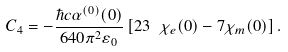<formula> <loc_0><loc_0><loc_500><loc_500>C _ { 4 } = - \frac { \hbar { c } \alpha ^ { ( 0 ) } ( 0 ) } { 6 4 0 \pi ^ { 2 } \varepsilon _ { 0 } } \left [ 2 3 \ \chi _ { e } ( 0 ) - 7 \chi _ { m } ( 0 ) \right ] .</formula> 